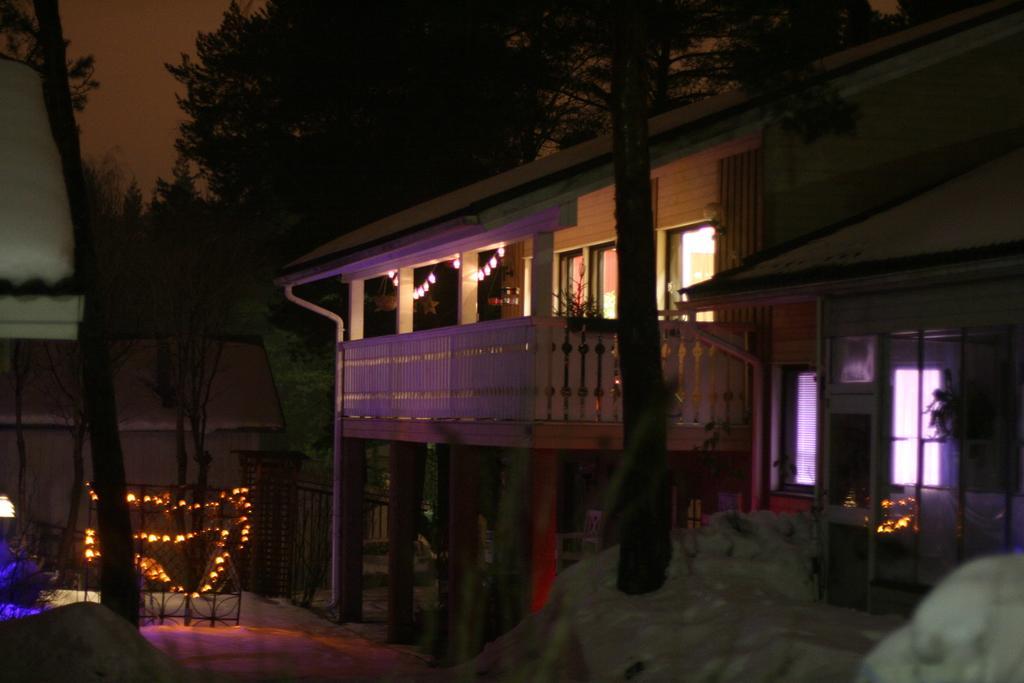Can you describe this image briefly? In this image we can see a house with roof, windows, door and some lights. We can also see a group of trees, the bark of a tree and some lights to a barricade and the sky. 